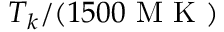<formula> <loc_0><loc_0><loc_500><loc_500>T _ { k } / ( 1 5 0 0 { M K } )</formula> 